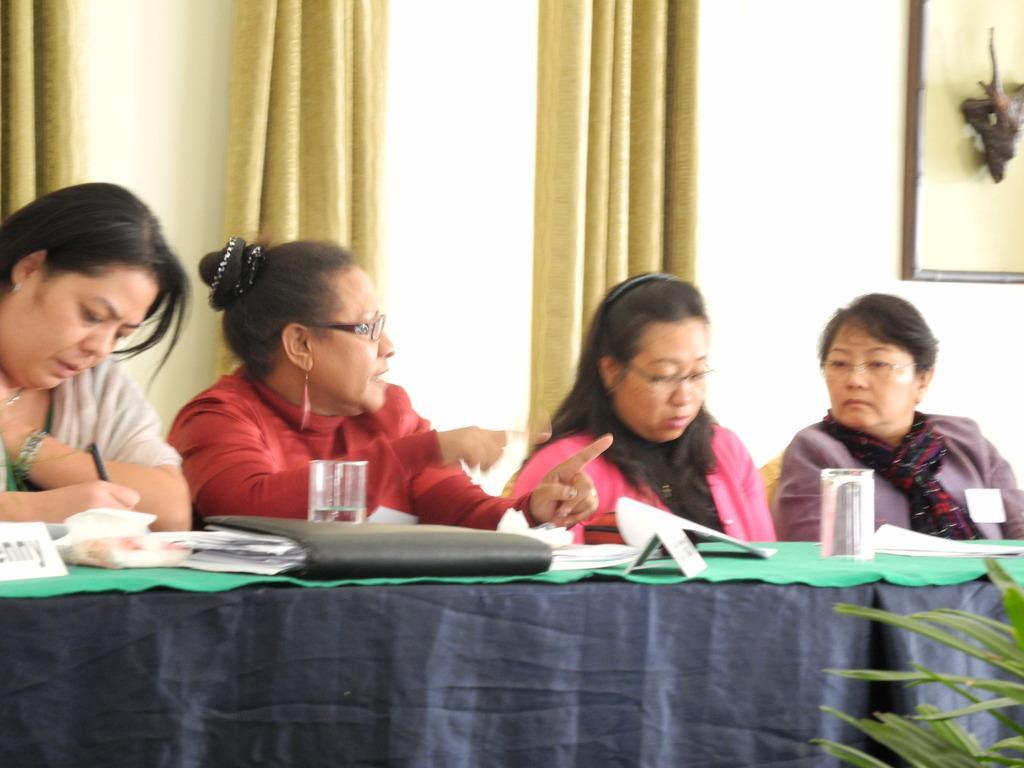Describe this image in one or two sentences. In this picture there are group of people those who are sitting on the chairs in the center of the image and there is a table in front of them, on which there are papers and glasses, there are curtains in the background area of the image. 